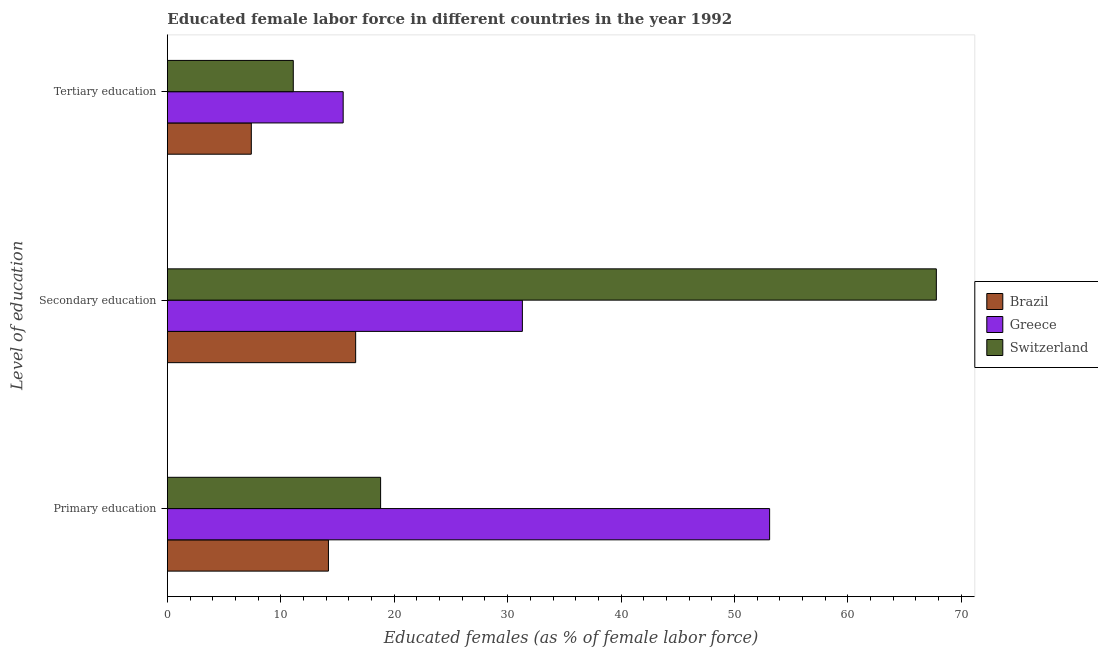Are the number of bars per tick equal to the number of legend labels?
Provide a succinct answer. Yes. Are the number of bars on each tick of the Y-axis equal?
Provide a succinct answer. Yes. How many bars are there on the 1st tick from the top?
Your response must be concise. 3. How many bars are there on the 3rd tick from the bottom?
Keep it short and to the point. 3. What is the percentage of female labor force who received primary education in Brazil?
Offer a very short reply. 14.2. Across all countries, what is the minimum percentage of female labor force who received primary education?
Offer a terse response. 14.2. In which country was the percentage of female labor force who received secondary education minimum?
Offer a very short reply. Brazil. What is the total percentage of female labor force who received tertiary education in the graph?
Offer a very short reply. 34. What is the difference between the percentage of female labor force who received tertiary education in Brazil and that in Greece?
Ensure brevity in your answer.  -8.1. What is the difference between the percentage of female labor force who received primary education in Switzerland and the percentage of female labor force who received tertiary education in Greece?
Your answer should be compact. 3.3. What is the average percentage of female labor force who received secondary education per country?
Your answer should be compact. 38.57. What is the difference between the percentage of female labor force who received tertiary education and percentage of female labor force who received primary education in Greece?
Ensure brevity in your answer.  -37.6. What is the ratio of the percentage of female labor force who received tertiary education in Greece to that in Brazil?
Ensure brevity in your answer.  2.09. What is the difference between the highest and the second highest percentage of female labor force who received primary education?
Provide a short and direct response. 34.3. What is the difference between the highest and the lowest percentage of female labor force who received primary education?
Your response must be concise. 38.9. What does the 3rd bar from the bottom in Tertiary education represents?
Your answer should be very brief. Switzerland. What is the difference between two consecutive major ticks on the X-axis?
Your response must be concise. 10. Where does the legend appear in the graph?
Provide a succinct answer. Center right. What is the title of the graph?
Your response must be concise. Educated female labor force in different countries in the year 1992. Does "American Samoa" appear as one of the legend labels in the graph?
Your answer should be compact. No. What is the label or title of the X-axis?
Keep it short and to the point. Educated females (as % of female labor force). What is the label or title of the Y-axis?
Your response must be concise. Level of education. What is the Educated females (as % of female labor force) of Brazil in Primary education?
Give a very brief answer. 14.2. What is the Educated females (as % of female labor force) in Greece in Primary education?
Offer a very short reply. 53.1. What is the Educated females (as % of female labor force) of Switzerland in Primary education?
Provide a short and direct response. 18.8. What is the Educated females (as % of female labor force) of Brazil in Secondary education?
Ensure brevity in your answer.  16.6. What is the Educated females (as % of female labor force) in Greece in Secondary education?
Offer a very short reply. 31.3. What is the Educated females (as % of female labor force) of Switzerland in Secondary education?
Provide a succinct answer. 67.8. What is the Educated females (as % of female labor force) in Brazil in Tertiary education?
Your answer should be very brief. 7.4. What is the Educated females (as % of female labor force) of Greece in Tertiary education?
Provide a short and direct response. 15.5. What is the Educated females (as % of female labor force) in Switzerland in Tertiary education?
Offer a terse response. 11.1. Across all Level of education, what is the maximum Educated females (as % of female labor force) of Brazil?
Give a very brief answer. 16.6. Across all Level of education, what is the maximum Educated females (as % of female labor force) of Greece?
Give a very brief answer. 53.1. Across all Level of education, what is the maximum Educated females (as % of female labor force) of Switzerland?
Ensure brevity in your answer.  67.8. Across all Level of education, what is the minimum Educated females (as % of female labor force) of Brazil?
Offer a terse response. 7.4. Across all Level of education, what is the minimum Educated females (as % of female labor force) in Greece?
Your answer should be compact. 15.5. Across all Level of education, what is the minimum Educated females (as % of female labor force) in Switzerland?
Your answer should be compact. 11.1. What is the total Educated females (as % of female labor force) of Brazil in the graph?
Provide a short and direct response. 38.2. What is the total Educated females (as % of female labor force) in Greece in the graph?
Provide a short and direct response. 99.9. What is the total Educated females (as % of female labor force) of Switzerland in the graph?
Keep it short and to the point. 97.7. What is the difference between the Educated females (as % of female labor force) of Brazil in Primary education and that in Secondary education?
Give a very brief answer. -2.4. What is the difference between the Educated females (as % of female labor force) in Greece in Primary education and that in Secondary education?
Your answer should be compact. 21.8. What is the difference between the Educated females (as % of female labor force) of Switzerland in Primary education and that in Secondary education?
Offer a very short reply. -49. What is the difference between the Educated females (as % of female labor force) in Brazil in Primary education and that in Tertiary education?
Provide a short and direct response. 6.8. What is the difference between the Educated females (as % of female labor force) of Greece in Primary education and that in Tertiary education?
Offer a terse response. 37.6. What is the difference between the Educated females (as % of female labor force) of Brazil in Secondary education and that in Tertiary education?
Give a very brief answer. 9.2. What is the difference between the Educated females (as % of female labor force) in Greece in Secondary education and that in Tertiary education?
Your response must be concise. 15.8. What is the difference between the Educated females (as % of female labor force) in Switzerland in Secondary education and that in Tertiary education?
Your response must be concise. 56.7. What is the difference between the Educated females (as % of female labor force) in Brazil in Primary education and the Educated females (as % of female labor force) in Greece in Secondary education?
Your answer should be very brief. -17.1. What is the difference between the Educated females (as % of female labor force) of Brazil in Primary education and the Educated females (as % of female labor force) of Switzerland in Secondary education?
Provide a short and direct response. -53.6. What is the difference between the Educated females (as % of female labor force) of Greece in Primary education and the Educated females (as % of female labor force) of Switzerland in Secondary education?
Give a very brief answer. -14.7. What is the difference between the Educated females (as % of female labor force) of Brazil in Secondary education and the Educated females (as % of female labor force) of Switzerland in Tertiary education?
Offer a very short reply. 5.5. What is the difference between the Educated females (as % of female labor force) of Greece in Secondary education and the Educated females (as % of female labor force) of Switzerland in Tertiary education?
Provide a short and direct response. 20.2. What is the average Educated females (as % of female labor force) of Brazil per Level of education?
Offer a terse response. 12.73. What is the average Educated females (as % of female labor force) of Greece per Level of education?
Your response must be concise. 33.3. What is the average Educated females (as % of female labor force) in Switzerland per Level of education?
Provide a short and direct response. 32.57. What is the difference between the Educated females (as % of female labor force) of Brazil and Educated females (as % of female labor force) of Greece in Primary education?
Provide a succinct answer. -38.9. What is the difference between the Educated females (as % of female labor force) in Brazil and Educated females (as % of female labor force) in Switzerland in Primary education?
Make the answer very short. -4.6. What is the difference between the Educated females (as % of female labor force) of Greece and Educated females (as % of female labor force) of Switzerland in Primary education?
Your answer should be very brief. 34.3. What is the difference between the Educated females (as % of female labor force) in Brazil and Educated females (as % of female labor force) in Greece in Secondary education?
Keep it short and to the point. -14.7. What is the difference between the Educated females (as % of female labor force) of Brazil and Educated females (as % of female labor force) of Switzerland in Secondary education?
Provide a succinct answer. -51.2. What is the difference between the Educated females (as % of female labor force) in Greece and Educated females (as % of female labor force) in Switzerland in Secondary education?
Give a very brief answer. -36.5. What is the difference between the Educated females (as % of female labor force) of Brazil and Educated females (as % of female labor force) of Greece in Tertiary education?
Make the answer very short. -8.1. What is the ratio of the Educated females (as % of female labor force) in Brazil in Primary education to that in Secondary education?
Your response must be concise. 0.86. What is the ratio of the Educated females (as % of female labor force) in Greece in Primary education to that in Secondary education?
Offer a very short reply. 1.7. What is the ratio of the Educated females (as % of female labor force) in Switzerland in Primary education to that in Secondary education?
Give a very brief answer. 0.28. What is the ratio of the Educated females (as % of female labor force) of Brazil in Primary education to that in Tertiary education?
Ensure brevity in your answer.  1.92. What is the ratio of the Educated females (as % of female labor force) in Greece in Primary education to that in Tertiary education?
Your answer should be very brief. 3.43. What is the ratio of the Educated females (as % of female labor force) in Switzerland in Primary education to that in Tertiary education?
Give a very brief answer. 1.69. What is the ratio of the Educated females (as % of female labor force) of Brazil in Secondary education to that in Tertiary education?
Your answer should be very brief. 2.24. What is the ratio of the Educated females (as % of female labor force) of Greece in Secondary education to that in Tertiary education?
Keep it short and to the point. 2.02. What is the ratio of the Educated females (as % of female labor force) in Switzerland in Secondary education to that in Tertiary education?
Ensure brevity in your answer.  6.11. What is the difference between the highest and the second highest Educated females (as % of female labor force) in Greece?
Give a very brief answer. 21.8. What is the difference between the highest and the second highest Educated females (as % of female labor force) of Switzerland?
Your answer should be compact. 49. What is the difference between the highest and the lowest Educated females (as % of female labor force) in Brazil?
Provide a short and direct response. 9.2. What is the difference between the highest and the lowest Educated females (as % of female labor force) of Greece?
Keep it short and to the point. 37.6. What is the difference between the highest and the lowest Educated females (as % of female labor force) of Switzerland?
Your answer should be very brief. 56.7. 